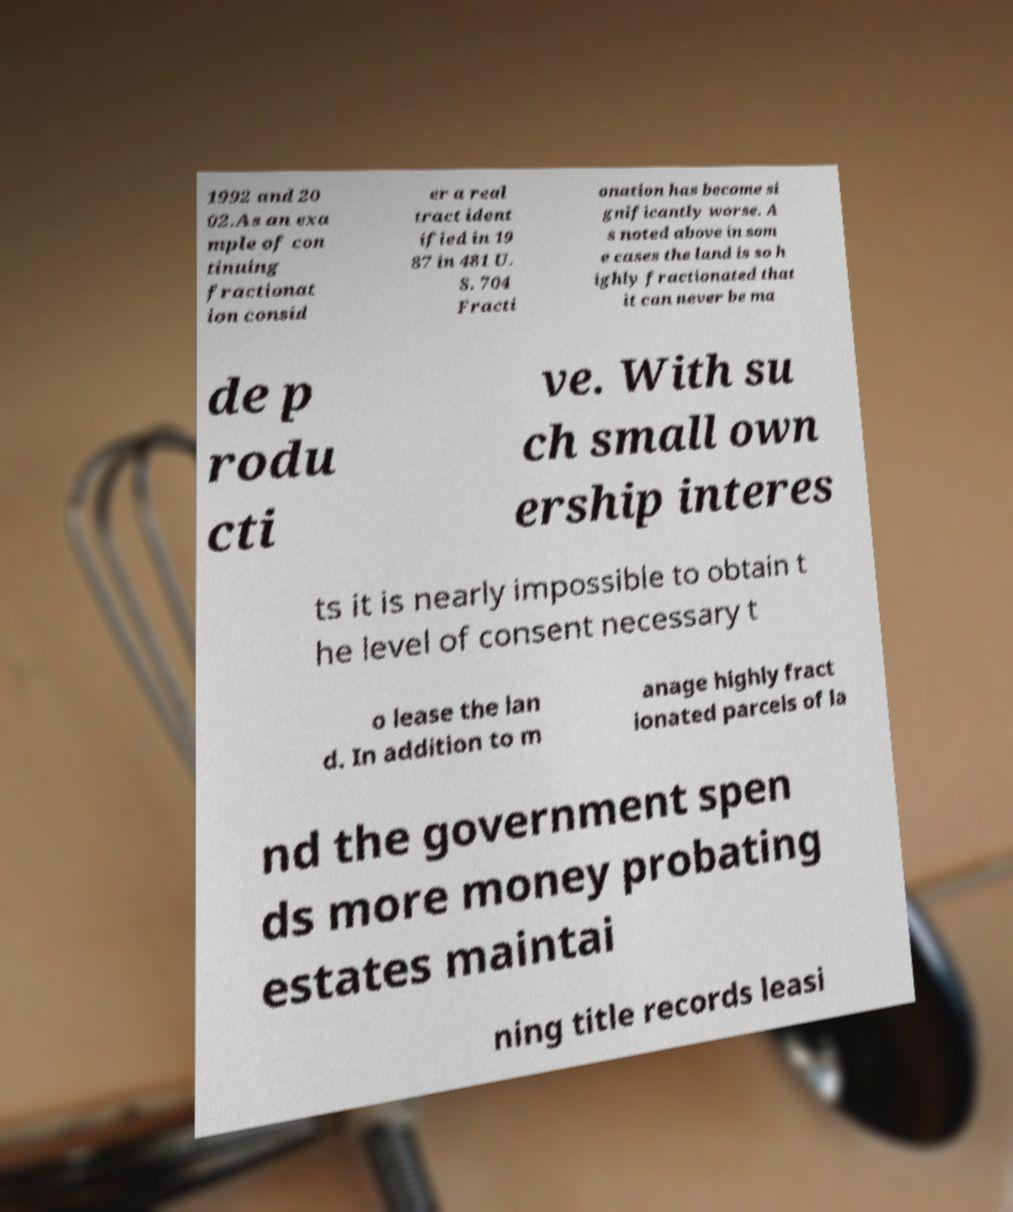Can you accurately transcribe the text from the provided image for me? 1992 and 20 02.As an exa mple of con tinuing fractionat ion consid er a real tract ident ified in 19 87 in 481 U. S. 704 Fracti onation has become si gnificantly worse. A s noted above in som e cases the land is so h ighly fractionated that it can never be ma de p rodu cti ve. With su ch small own ership interes ts it is nearly impossible to obtain t he level of consent necessary t o lease the lan d. In addition to m anage highly fract ionated parcels of la nd the government spen ds more money probating estates maintai ning title records leasi 